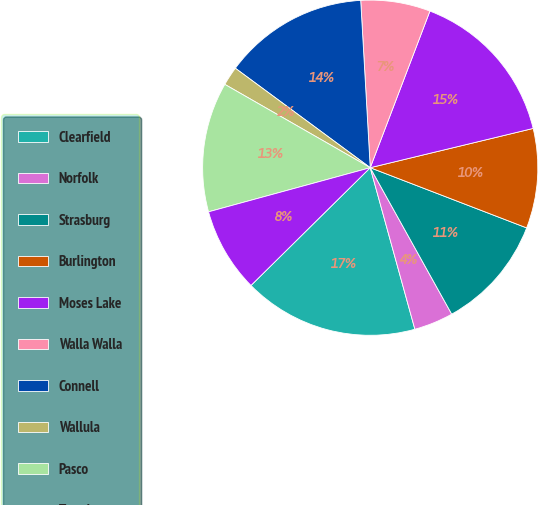Convert chart to OTSL. <chart><loc_0><loc_0><loc_500><loc_500><pie_chart><fcel>Clearfield<fcel>Norfolk<fcel>Strasburg<fcel>Burlington<fcel>Moses Lake<fcel>Walla Walla<fcel>Connell<fcel>Wallula<fcel>Pasco<fcel>Tomah<nl><fcel>16.89%<fcel>3.79%<fcel>11.07%<fcel>9.61%<fcel>15.44%<fcel>6.7%<fcel>13.98%<fcel>1.83%<fcel>12.52%<fcel>8.16%<nl></chart> 